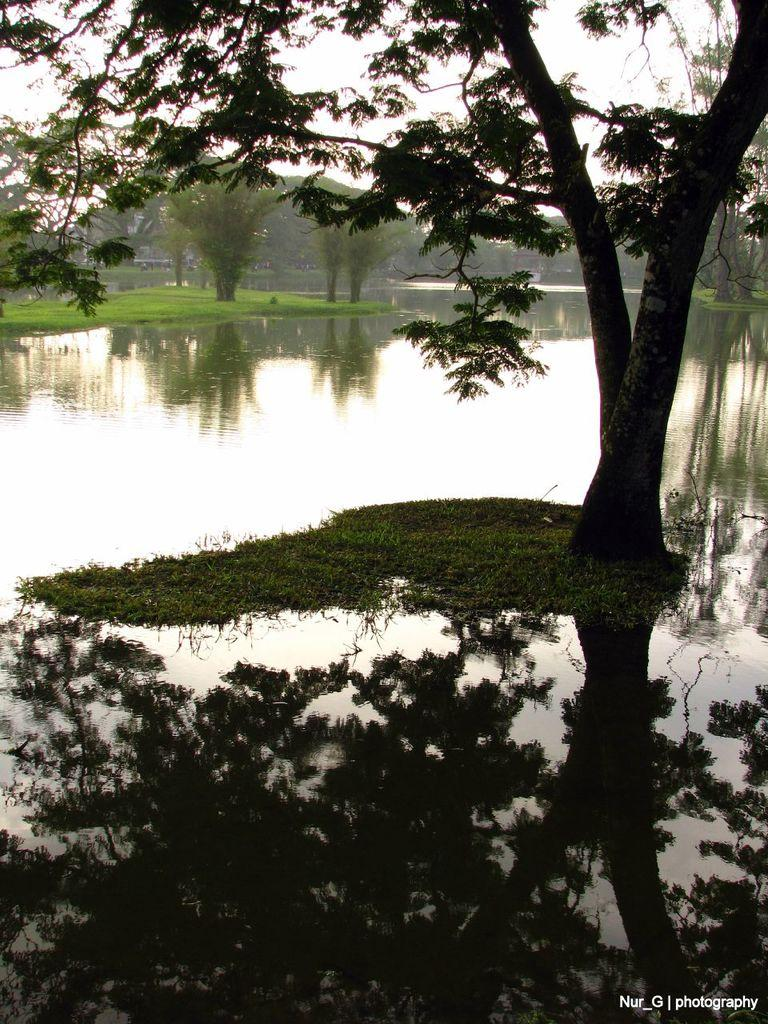What is one of the natural elements present in the image? There is water in the image. What type of vegetation can be seen in the image? There is grass and trees in the image. Does the water in the image have any specific characteristics? Yes, the water in the image has a reflection. Is there any additional information about the image itself? There is a watermark in the image. What type of seed is being planted in the river in the image? There is no river or seed present in the image; it features water, grass, and trees. How does the butter affect the growth of the plants in the image? There is no butter present in the image, so its effect on the plants cannot be determined. 